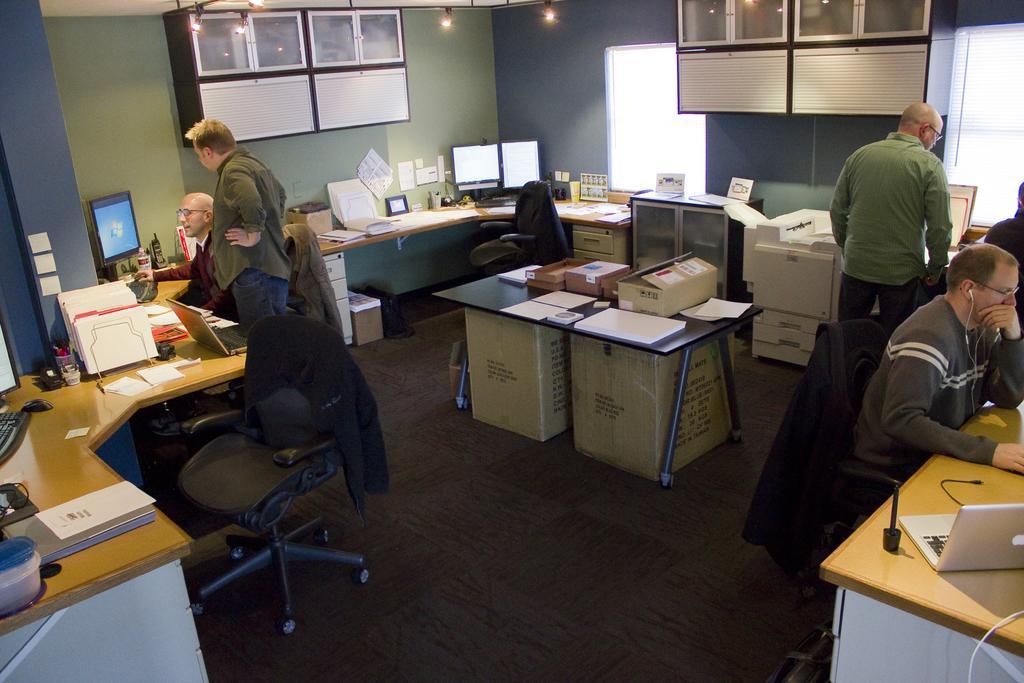Can you describe this image briefly? This picture shows couple of them seated on the chairs and two of them standing and we see computers and laptops on the table and we see few papers and boxes 